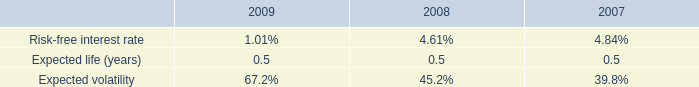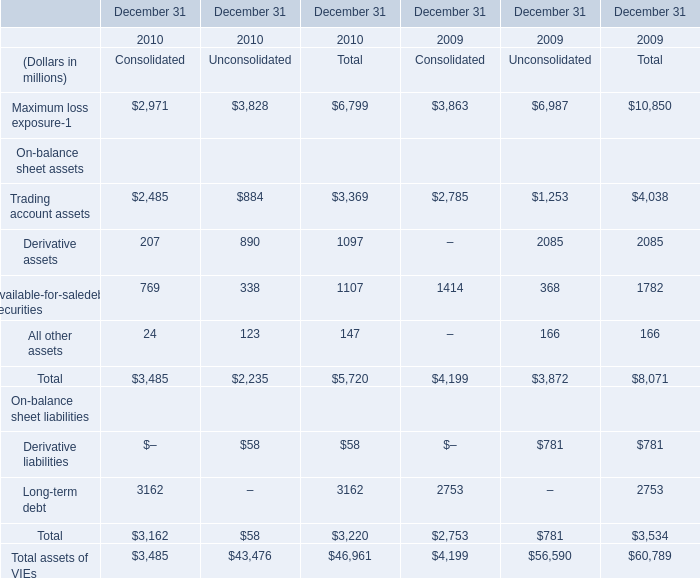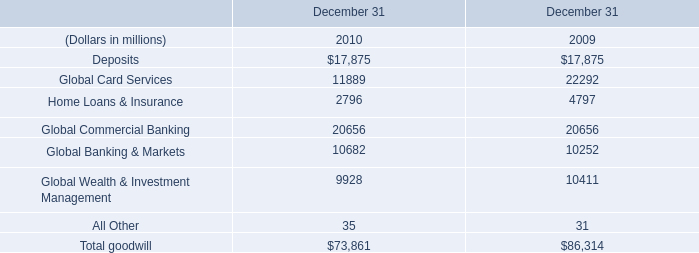What will Available-for-saledebt securities in unconsolidated be like in 2011 if it continues to grow at the same rate as it did in 2010? (in millions) 
Computations: ((1 + ((338 - 368) / 368)) * 338)
Answer: 310.44565. 